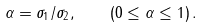<formula> <loc_0><loc_0><loc_500><loc_500>\alpha = \sigma _ { 1 } / \sigma _ { 2 } , \quad ( 0 \leq \alpha \leq 1 ) \, .</formula> 